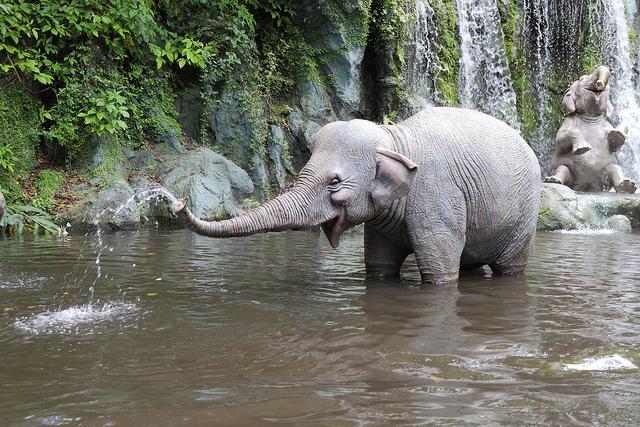Is the elephant laughing?
Answer briefly. No. Are these two elephants life partners?
Give a very brief answer. Yes. Is the elephant eating?
Quick response, please. No. What is the elephant using to squirt water?
Be succinct. Trunk. What type of substance surrounds the center elephant?
Be succinct. Water. 